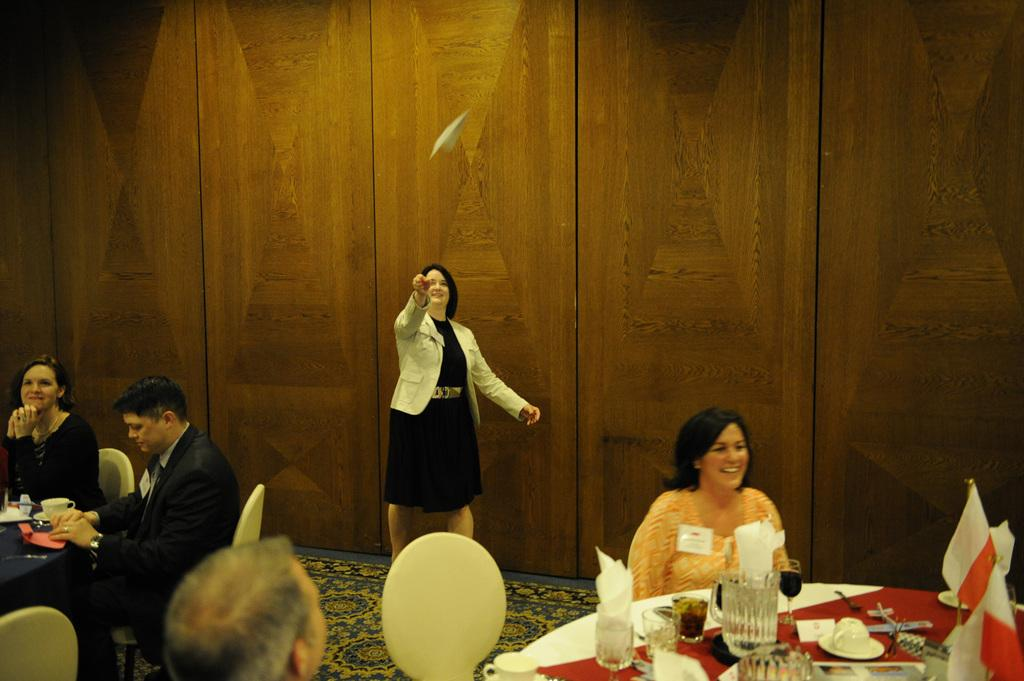What are the people in the image doing? People are sitting in chairs at tables. Can you describe the woman in the background? The woman in the background is throwing a paper plane. How many babies are crawling on the floor in the image? There are no babies present in the image. What type of teeth can be seen in the image? There are no teeth visible in the image. 